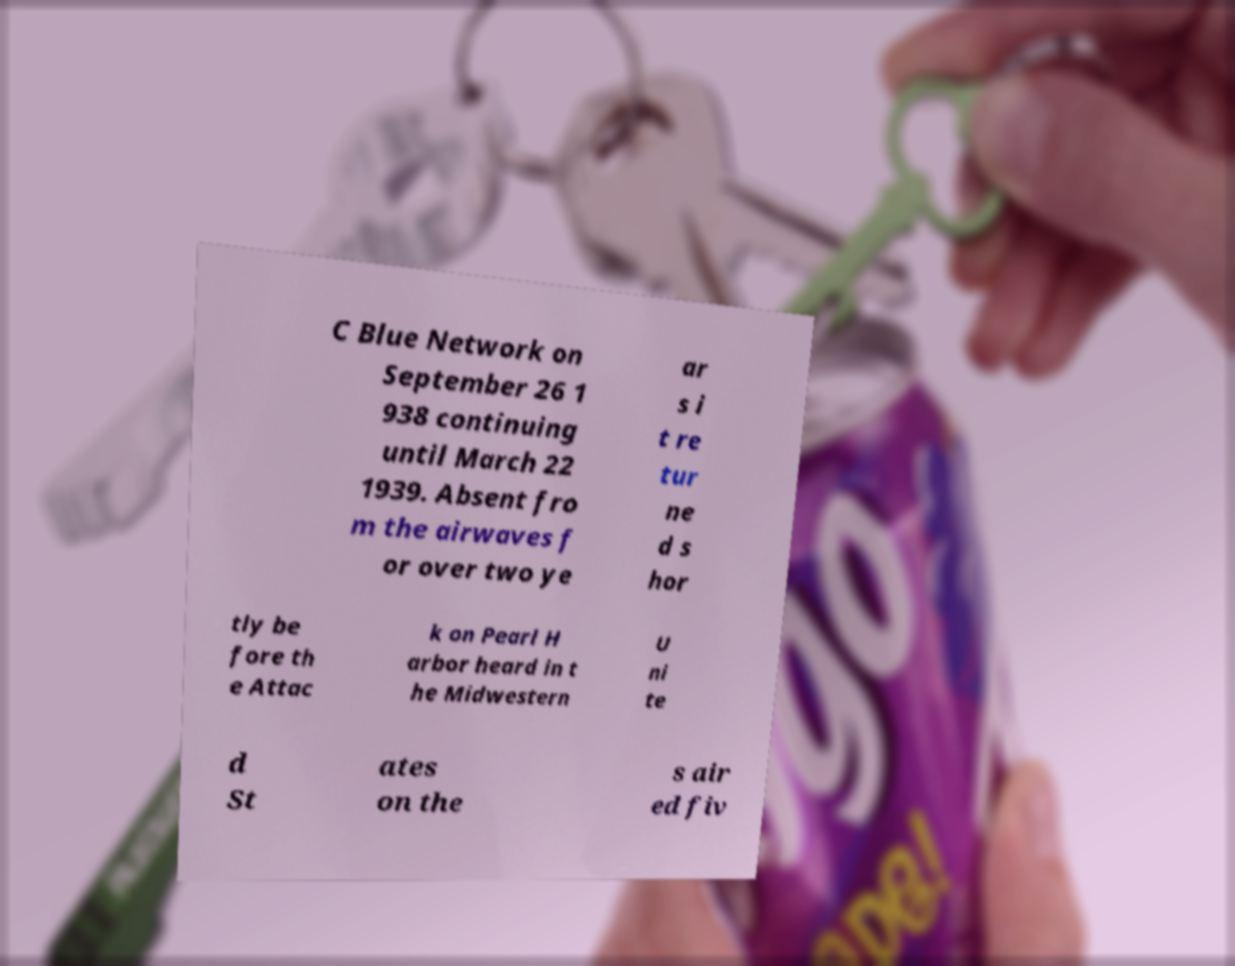What messages or text are displayed in this image? I need them in a readable, typed format. C Blue Network on September 26 1 938 continuing until March 22 1939. Absent fro m the airwaves f or over two ye ar s i t re tur ne d s hor tly be fore th e Attac k on Pearl H arbor heard in t he Midwestern U ni te d St ates on the s air ed fiv 